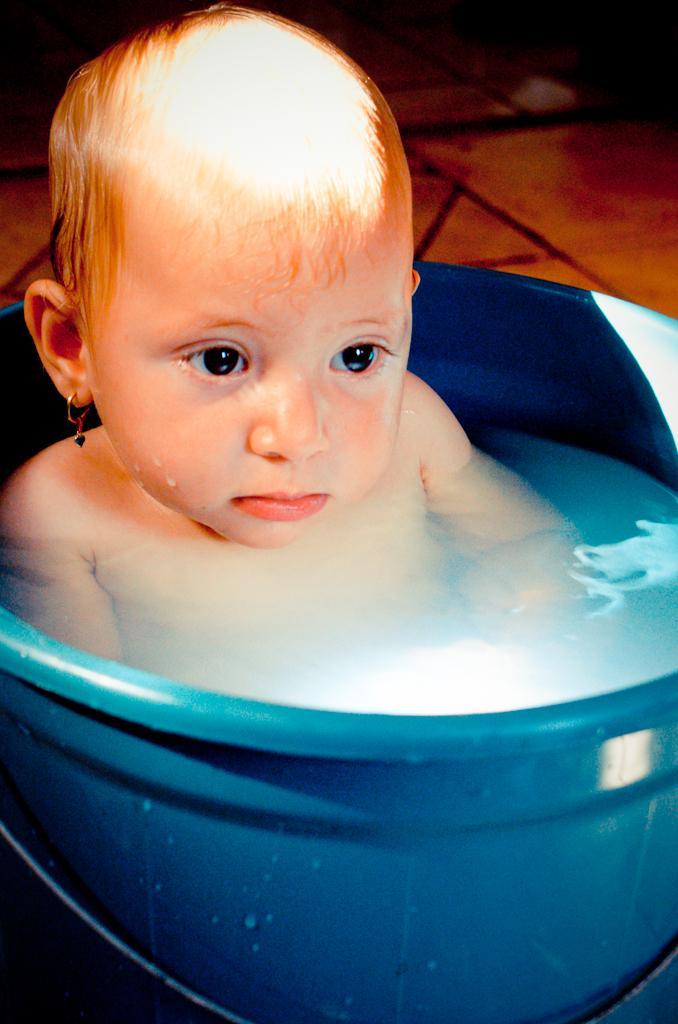Describe this image in one or two sentences. In this image there is a kid in a bucket of water, and in the background there are tiles. 